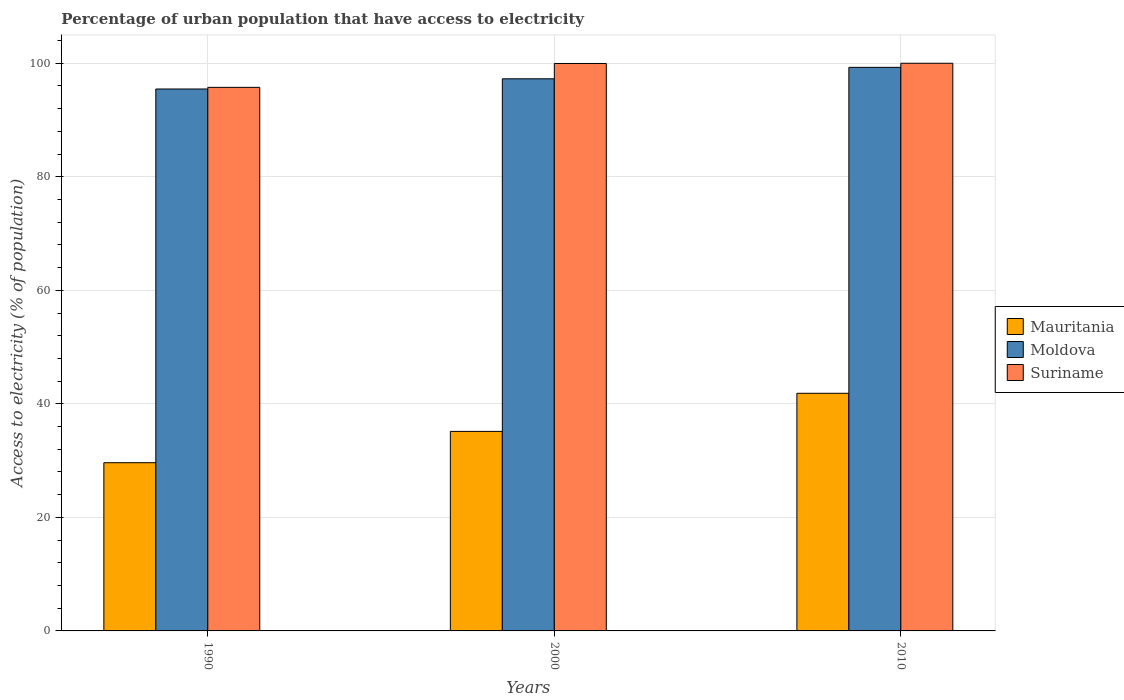Are the number of bars on each tick of the X-axis equal?
Ensure brevity in your answer.  Yes. How many bars are there on the 2nd tick from the left?
Offer a very short reply. 3. What is the label of the 3rd group of bars from the left?
Provide a short and direct response. 2010. What is the percentage of urban population that have access to electricity in Mauritania in 2010?
Ensure brevity in your answer.  41.86. Across all years, what is the maximum percentage of urban population that have access to electricity in Moldova?
Offer a terse response. 99.28. Across all years, what is the minimum percentage of urban population that have access to electricity in Moldova?
Make the answer very short. 95.47. In which year was the percentage of urban population that have access to electricity in Moldova minimum?
Ensure brevity in your answer.  1990. What is the total percentage of urban population that have access to electricity in Suriname in the graph?
Ensure brevity in your answer.  295.72. What is the difference between the percentage of urban population that have access to electricity in Mauritania in 1990 and that in 2000?
Offer a very short reply. -5.52. What is the difference between the percentage of urban population that have access to electricity in Suriname in 2000 and the percentage of urban population that have access to electricity in Mauritania in 2010?
Offer a very short reply. 58.1. What is the average percentage of urban population that have access to electricity in Moldova per year?
Provide a short and direct response. 97.34. In the year 2000, what is the difference between the percentage of urban population that have access to electricity in Suriname and percentage of urban population that have access to electricity in Mauritania?
Provide a succinct answer. 64.81. In how many years, is the percentage of urban population that have access to electricity in Moldova greater than 44 %?
Ensure brevity in your answer.  3. What is the ratio of the percentage of urban population that have access to electricity in Mauritania in 1990 to that in 2000?
Offer a very short reply. 0.84. Is the difference between the percentage of urban population that have access to electricity in Suriname in 1990 and 2000 greater than the difference between the percentage of urban population that have access to electricity in Mauritania in 1990 and 2000?
Provide a short and direct response. Yes. What is the difference between the highest and the second highest percentage of urban population that have access to electricity in Suriname?
Your answer should be compact. 0.04. What is the difference between the highest and the lowest percentage of urban population that have access to electricity in Suriname?
Make the answer very short. 4.24. In how many years, is the percentage of urban population that have access to electricity in Moldova greater than the average percentage of urban population that have access to electricity in Moldova taken over all years?
Ensure brevity in your answer.  1. Is the sum of the percentage of urban population that have access to electricity in Mauritania in 1990 and 2010 greater than the maximum percentage of urban population that have access to electricity in Suriname across all years?
Your response must be concise. No. What does the 1st bar from the left in 2000 represents?
Keep it short and to the point. Mauritania. What does the 1st bar from the right in 2010 represents?
Provide a succinct answer. Suriname. Is it the case that in every year, the sum of the percentage of urban population that have access to electricity in Mauritania and percentage of urban population that have access to electricity in Suriname is greater than the percentage of urban population that have access to electricity in Moldova?
Your response must be concise. Yes. How many bars are there?
Provide a succinct answer. 9. Are the values on the major ticks of Y-axis written in scientific E-notation?
Provide a short and direct response. No. Does the graph contain any zero values?
Provide a short and direct response. No. How many legend labels are there?
Offer a very short reply. 3. How are the legend labels stacked?
Offer a very short reply. Vertical. What is the title of the graph?
Your answer should be compact. Percentage of urban population that have access to electricity. Does "Bolivia" appear as one of the legend labels in the graph?
Ensure brevity in your answer.  No. What is the label or title of the Y-axis?
Keep it short and to the point. Access to electricity (% of population). What is the Access to electricity (% of population) of Mauritania in 1990?
Offer a terse response. 29.63. What is the Access to electricity (% of population) of Moldova in 1990?
Ensure brevity in your answer.  95.47. What is the Access to electricity (% of population) in Suriname in 1990?
Keep it short and to the point. 95.76. What is the Access to electricity (% of population) of Mauritania in 2000?
Offer a very short reply. 35.15. What is the Access to electricity (% of population) of Moldova in 2000?
Make the answer very short. 97.26. What is the Access to electricity (% of population) of Suriname in 2000?
Your answer should be very brief. 99.96. What is the Access to electricity (% of population) in Mauritania in 2010?
Keep it short and to the point. 41.86. What is the Access to electricity (% of population) of Moldova in 2010?
Offer a very short reply. 99.28. Across all years, what is the maximum Access to electricity (% of population) in Mauritania?
Offer a very short reply. 41.86. Across all years, what is the maximum Access to electricity (% of population) of Moldova?
Provide a succinct answer. 99.28. Across all years, what is the maximum Access to electricity (% of population) in Suriname?
Give a very brief answer. 100. Across all years, what is the minimum Access to electricity (% of population) in Mauritania?
Your answer should be compact. 29.63. Across all years, what is the minimum Access to electricity (% of population) of Moldova?
Your response must be concise. 95.47. Across all years, what is the minimum Access to electricity (% of population) of Suriname?
Offer a terse response. 95.76. What is the total Access to electricity (% of population) of Mauritania in the graph?
Provide a succinct answer. 106.64. What is the total Access to electricity (% of population) in Moldova in the graph?
Make the answer very short. 292.01. What is the total Access to electricity (% of population) in Suriname in the graph?
Provide a short and direct response. 295.72. What is the difference between the Access to electricity (% of population) of Mauritania in 1990 and that in 2000?
Your response must be concise. -5.52. What is the difference between the Access to electricity (% of population) in Moldova in 1990 and that in 2000?
Provide a succinct answer. -1.8. What is the difference between the Access to electricity (% of population) of Suriname in 1990 and that in 2000?
Your answer should be very brief. -4.21. What is the difference between the Access to electricity (% of population) of Mauritania in 1990 and that in 2010?
Your answer should be compact. -12.23. What is the difference between the Access to electricity (% of population) of Moldova in 1990 and that in 2010?
Give a very brief answer. -3.81. What is the difference between the Access to electricity (% of population) of Suriname in 1990 and that in 2010?
Ensure brevity in your answer.  -4.24. What is the difference between the Access to electricity (% of population) of Mauritania in 2000 and that in 2010?
Make the answer very short. -6.71. What is the difference between the Access to electricity (% of population) in Moldova in 2000 and that in 2010?
Provide a succinct answer. -2.02. What is the difference between the Access to electricity (% of population) of Suriname in 2000 and that in 2010?
Offer a terse response. -0.04. What is the difference between the Access to electricity (% of population) of Mauritania in 1990 and the Access to electricity (% of population) of Moldova in 2000?
Give a very brief answer. -67.63. What is the difference between the Access to electricity (% of population) in Mauritania in 1990 and the Access to electricity (% of population) in Suriname in 2000?
Your answer should be very brief. -70.33. What is the difference between the Access to electricity (% of population) in Moldova in 1990 and the Access to electricity (% of population) in Suriname in 2000?
Offer a terse response. -4.5. What is the difference between the Access to electricity (% of population) in Mauritania in 1990 and the Access to electricity (% of population) in Moldova in 2010?
Ensure brevity in your answer.  -69.65. What is the difference between the Access to electricity (% of population) in Mauritania in 1990 and the Access to electricity (% of population) in Suriname in 2010?
Keep it short and to the point. -70.37. What is the difference between the Access to electricity (% of population) in Moldova in 1990 and the Access to electricity (% of population) in Suriname in 2010?
Provide a succinct answer. -4.53. What is the difference between the Access to electricity (% of population) in Mauritania in 2000 and the Access to electricity (% of population) in Moldova in 2010?
Provide a short and direct response. -64.13. What is the difference between the Access to electricity (% of population) in Mauritania in 2000 and the Access to electricity (% of population) in Suriname in 2010?
Provide a succinct answer. -64.85. What is the difference between the Access to electricity (% of population) in Moldova in 2000 and the Access to electricity (% of population) in Suriname in 2010?
Make the answer very short. -2.74. What is the average Access to electricity (% of population) in Mauritania per year?
Offer a very short reply. 35.55. What is the average Access to electricity (% of population) of Moldova per year?
Offer a very short reply. 97.34. What is the average Access to electricity (% of population) in Suriname per year?
Ensure brevity in your answer.  98.57. In the year 1990, what is the difference between the Access to electricity (% of population) in Mauritania and Access to electricity (% of population) in Moldova?
Give a very brief answer. -65.83. In the year 1990, what is the difference between the Access to electricity (% of population) of Mauritania and Access to electricity (% of population) of Suriname?
Your answer should be compact. -66.12. In the year 1990, what is the difference between the Access to electricity (% of population) of Moldova and Access to electricity (% of population) of Suriname?
Offer a very short reply. -0.29. In the year 2000, what is the difference between the Access to electricity (% of population) in Mauritania and Access to electricity (% of population) in Moldova?
Make the answer very short. -62.11. In the year 2000, what is the difference between the Access to electricity (% of population) in Mauritania and Access to electricity (% of population) in Suriname?
Ensure brevity in your answer.  -64.81. In the year 2000, what is the difference between the Access to electricity (% of population) in Moldova and Access to electricity (% of population) in Suriname?
Your answer should be very brief. -2.7. In the year 2010, what is the difference between the Access to electricity (% of population) of Mauritania and Access to electricity (% of population) of Moldova?
Your answer should be very brief. -57.42. In the year 2010, what is the difference between the Access to electricity (% of population) of Mauritania and Access to electricity (% of population) of Suriname?
Ensure brevity in your answer.  -58.14. In the year 2010, what is the difference between the Access to electricity (% of population) of Moldova and Access to electricity (% of population) of Suriname?
Keep it short and to the point. -0.72. What is the ratio of the Access to electricity (% of population) in Mauritania in 1990 to that in 2000?
Your answer should be very brief. 0.84. What is the ratio of the Access to electricity (% of population) in Moldova in 1990 to that in 2000?
Keep it short and to the point. 0.98. What is the ratio of the Access to electricity (% of population) of Suriname in 1990 to that in 2000?
Keep it short and to the point. 0.96. What is the ratio of the Access to electricity (% of population) of Mauritania in 1990 to that in 2010?
Your answer should be compact. 0.71. What is the ratio of the Access to electricity (% of population) in Moldova in 1990 to that in 2010?
Keep it short and to the point. 0.96. What is the ratio of the Access to electricity (% of population) in Suriname in 1990 to that in 2010?
Provide a short and direct response. 0.96. What is the ratio of the Access to electricity (% of population) in Mauritania in 2000 to that in 2010?
Your answer should be very brief. 0.84. What is the ratio of the Access to electricity (% of population) in Moldova in 2000 to that in 2010?
Provide a succinct answer. 0.98. What is the ratio of the Access to electricity (% of population) in Suriname in 2000 to that in 2010?
Offer a terse response. 1. What is the difference between the highest and the second highest Access to electricity (% of population) of Mauritania?
Your answer should be compact. 6.71. What is the difference between the highest and the second highest Access to electricity (% of population) of Moldova?
Your response must be concise. 2.02. What is the difference between the highest and the second highest Access to electricity (% of population) in Suriname?
Provide a short and direct response. 0.04. What is the difference between the highest and the lowest Access to electricity (% of population) in Mauritania?
Your answer should be very brief. 12.23. What is the difference between the highest and the lowest Access to electricity (% of population) in Moldova?
Give a very brief answer. 3.81. What is the difference between the highest and the lowest Access to electricity (% of population) of Suriname?
Give a very brief answer. 4.24. 